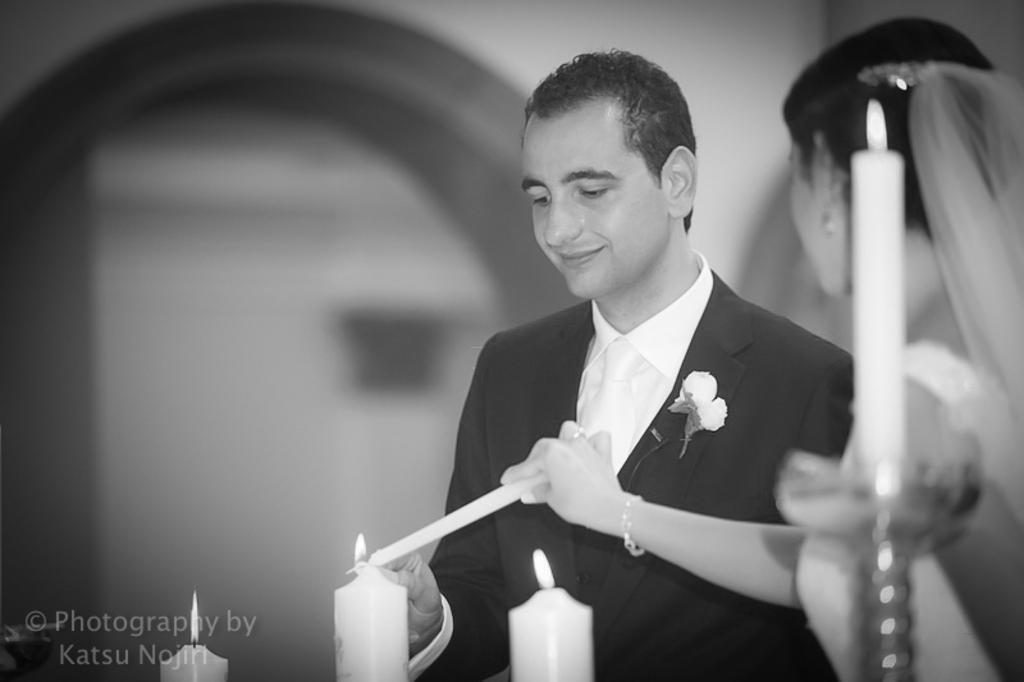Could you give a brief overview of what you see in this image? In this picture I can see there is a woman on to right side, she is wearing a white dress and holding candle and there is a man standing next to her and he is looking at the candles and smiling. He is wearing a black blazer and a white shirt. There is a water mark on the left bottom of the image and the backdrop is blurred. 